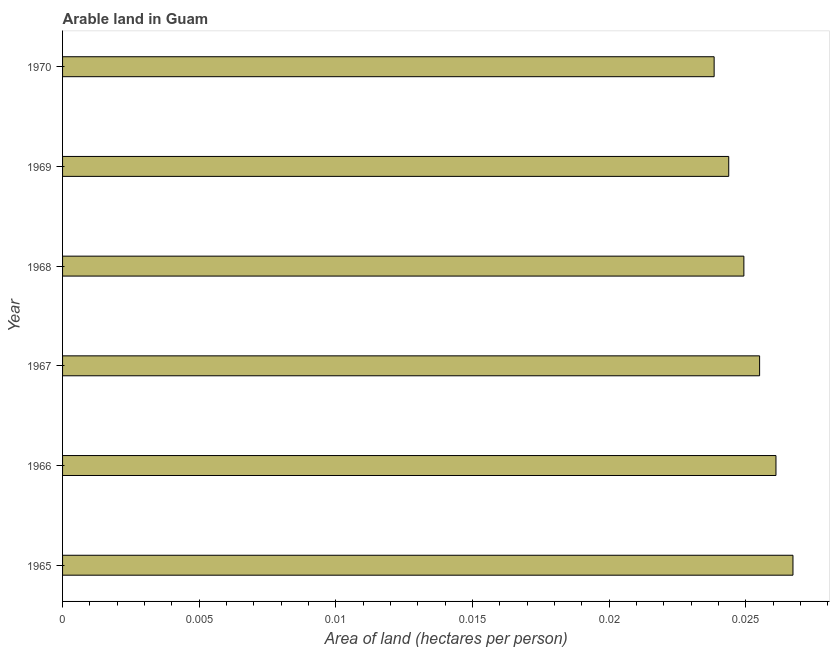Does the graph contain any zero values?
Ensure brevity in your answer.  No. What is the title of the graph?
Give a very brief answer. Arable land in Guam. What is the label or title of the X-axis?
Provide a short and direct response. Area of land (hectares per person). What is the label or title of the Y-axis?
Provide a succinct answer. Year. What is the area of arable land in 1967?
Make the answer very short. 0.03. Across all years, what is the maximum area of arable land?
Keep it short and to the point. 0.03. Across all years, what is the minimum area of arable land?
Offer a terse response. 0.02. In which year was the area of arable land maximum?
Your response must be concise. 1965. What is the sum of the area of arable land?
Your answer should be compact. 0.15. What is the difference between the area of arable land in 1966 and 1967?
Give a very brief answer. 0. What is the average area of arable land per year?
Your answer should be very brief. 0.03. What is the median area of arable land?
Offer a terse response. 0.03. Do a majority of the years between 1965 and 1968 (inclusive) have area of arable land greater than 0.007 hectares per person?
Make the answer very short. Yes. What is the ratio of the area of arable land in 1968 to that in 1969?
Your answer should be very brief. 1.02. Is the area of arable land in 1969 less than that in 1970?
Provide a short and direct response. No. In how many years, is the area of arable land greater than the average area of arable land taken over all years?
Offer a very short reply. 3. How many years are there in the graph?
Provide a succinct answer. 6. What is the difference between two consecutive major ticks on the X-axis?
Your response must be concise. 0.01. Are the values on the major ticks of X-axis written in scientific E-notation?
Your answer should be very brief. No. What is the Area of land (hectares per person) of 1965?
Offer a terse response. 0.03. What is the Area of land (hectares per person) of 1966?
Ensure brevity in your answer.  0.03. What is the Area of land (hectares per person) in 1967?
Your answer should be compact. 0.03. What is the Area of land (hectares per person) of 1968?
Give a very brief answer. 0.02. What is the Area of land (hectares per person) of 1969?
Give a very brief answer. 0.02. What is the Area of land (hectares per person) in 1970?
Your answer should be compact. 0.02. What is the difference between the Area of land (hectares per person) in 1965 and 1966?
Offer a terse response. 0. What is the difference between the Area of land (hectares per person) in 1965 and 1967?
Provide a short and direct response. 0. What is the difference between the Area of land (hectares per person) in 1965 and 1968?
Make the answer very short. 0. What is the difference between the Area of land (hectares per person) in 1965 and 1969?
Ensure brevity in your answer.  0. What is the difference between the Area of land (hectares per person) in 1965 and 1970?
Your answer should be very brief. 0. What is the difference between the Area of land (hectares per person) in 1966 and 1967?
Provide a short and direct response. 0. What is the difference between the Area of land (hectares per person) in 1966 and 1968?
Your response must be concise. 0. What is the difference between the Area of land (hectares per person) in 1966 and 1969?
Provide a succinct answer. 0. What is the difference between the Area of land (hectares per person) in 1966 and 1970?
Offer a terse response. 0. What is the difference between the Area of land (hectares per person) in 1967 and 1968?
Give a very brief answer. 0. What is the difference between the Area of land (hectares per person) in 1967 and 1969?
Make the answer very short. 0. What is the difference between the Area of land (hectares per person) in 1967 and 1970?
Give a very brief answer. 0. What is the difference between the Area of land (hectares per person) in 1968 and 1969?
Your answer should be very brief. 0. What is the difference between the Area of land (hectares per person) in 1968 and 1970?
Provide a succinct answer. 0. What is the difference between the Area of land (hectares per person) in 1969 and 1970?
Give a very brief answer. 0. What is the ratio of the Area of land (hectares per person) in 1965 to that in 1966?
Ensure brevity in your answer.  1.02. What is the ratio of the Area of land (hectares per person) in 1965 to that in 1967?
Your answer should be very brief. 1.05. What is the ratio of the Area of land (hectares per person) in 1965 to that in 1968?
Your answer should be compact. 1.07. What is the ratio of the Area of land (hectares per person) in 1965 to that in 1969?
Provide a succinct answer. 1.1. What is the ratio of the Area of land (hectares per person) in 1965 to that in 1970?
Offer a terse response. 1.12. What is the ratio of the Area of land (hectares per person) in 1966 to that in 1968?
Ensure brevity in your answer.  1.05. What is the ratio of the Area of land (hectares per person) in 1966 to that in 1969?
Ensure brevity in your answer.  1.07. What is the ratio of the Area of land (hectares per person) in 1966 to that in 1970?
Offer a terse response. 1.09. What is the ratio of the Area of land (hectares per person) in 1967 to that in 1968?
Make the answer very short. 1.02. What is the ratio of the Area of land (hectares per person) in 1967 to that in 1969?
Provide a short and direct response. 1.05. What is the ratio of the Area of land (hectares per person) in 1967 to that in 1970?
Give a very brief answer. 1.07. What is the ratio of the Area of land (hectares per person) in 1968 to that in 1969?
Your response must be concise. 1.02. What is the ratio of the Area of land (hectares per person) in 1968 to that in 1970?
Your response must be concise. 1.05. 